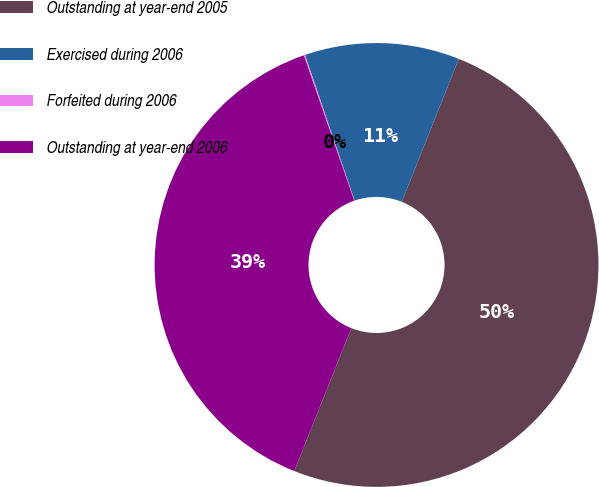Convert chart to OTSL. <chart><loc_0><loc_0><loc_500><loc_500><pie_chart><fcel>Outstanding at year-end 2005<fcel>Exercised during 2006<fcel>Forfeited during 2006<fcel>Outstanding at year-end 2006<nl><fcel>50.0%<fcel>11.27%<fcel>0.09%<fcel>38.64%<nl></chart> 